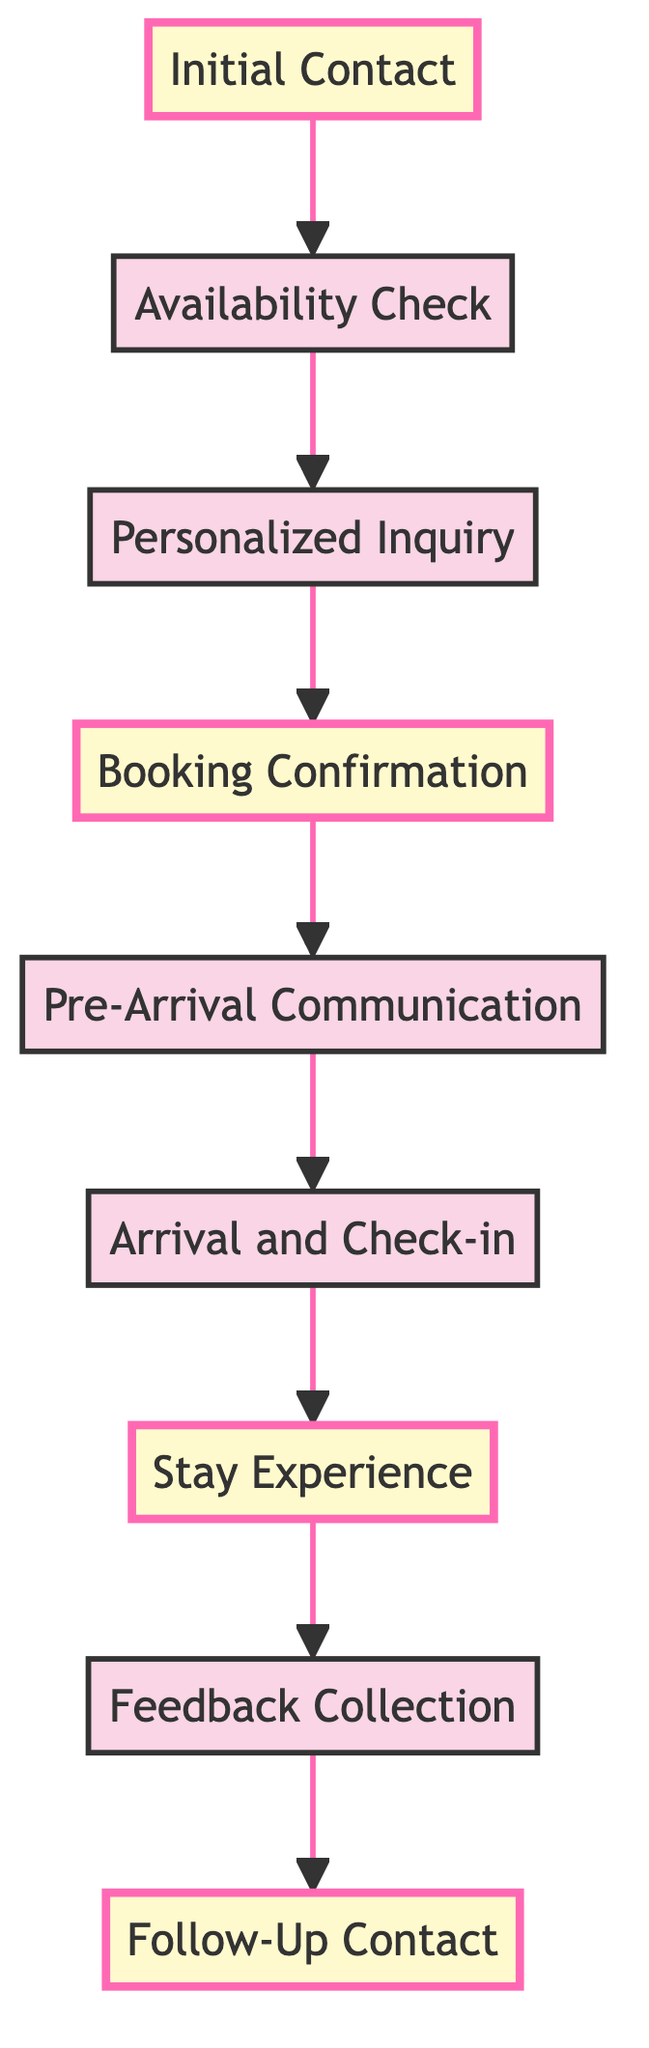What is the starting point of the flow chart? The flow chart begins with "Initial Contact" as the first node, representing the first interaction with potential guests.
Answer: Initial Contact How many main steps are there in the process? The diagram consists of nine distinct steps, each represented by a node from "Initial Contact" through to "Follow-Up Contact."
Answer: 9 What is the final step in the flow chart? The last node in the diagram is "Follow-Up Contact," which signifies the conclusion of the process after the stay experience.
Answer: Follow-Up Contact Which step involves gathering information about guest preferences? The node "Personalized Inquiry" is responsible for collecting details about guests' preferences and special requests.
Answer: Personalized Inquiry What node directly follows the "Booking Confirmation"? After "Booking Confirmation," the next step in the flow chart is "Pre-Arrival Communication," indicating that communication continues once the booking is confirmed.
Answer: Pre-Arrival Communication What is the relationship between "Stay Experience" and "Feedback Collection"? "Stay Experience" occurs before "Feedback Collection," which implies that guests are asked for feedback only after their stay experience is completed.
Answer: Stay Experience occurs before Feedback Collection Which step highlights personalized attention throughout the guests' stay? The node "Stay Experience" emphasizes the importance of providing personalized attention and services during the guests' stay.
Answer: Stay Experience In which step is local area information shared? "Pre-Arrival Communication" is the step where local area information, weather updates, and transportation options are shared with guests before their arrival.
Answer: Pre-Arrival Communication What is indicated by the highlighted nodes in the flow chart? The highlighted nodes "Initial Contact," "Booking Confirmation," "Stay Experience," and "Follow-Up Contact" signify key interaction points in the process that require particular attention.
Answer: Key interaction points 